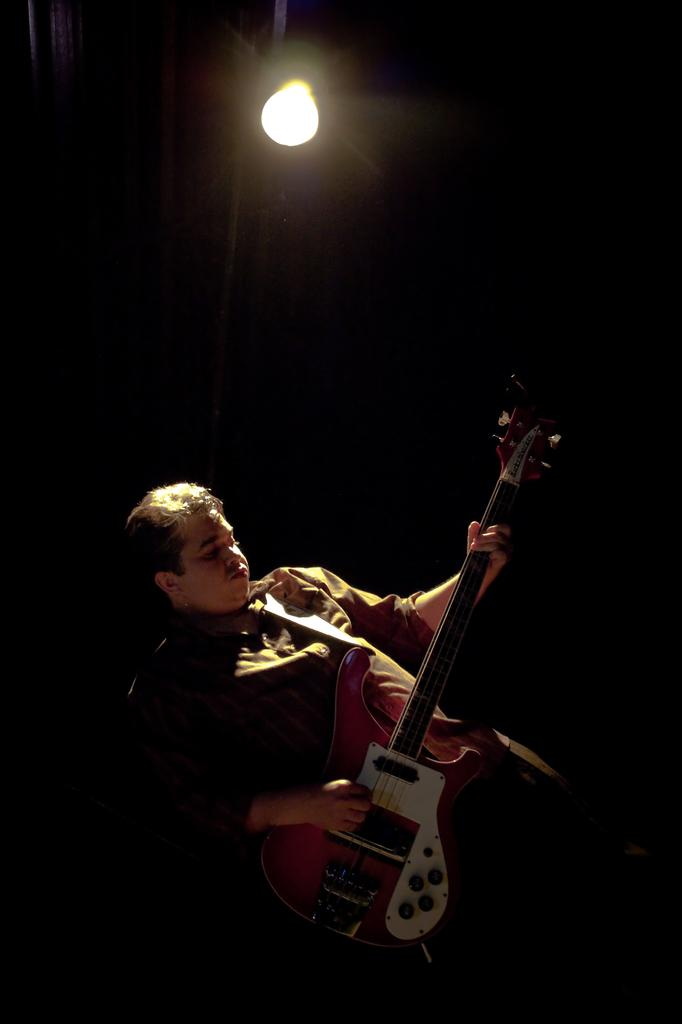What is the man in the image doing? The man is playing a guitar. Can you describe any additional features of the guitar? Yes, there is a light on top of the guitar. What subject is the man teaching to the monkey in the image? There is no monkey present in the image, and therefore no teaching activity can be observed. 